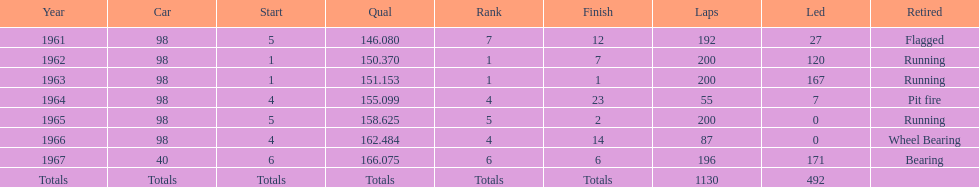In how many indy 500 races, has jones been flagged? 1. 